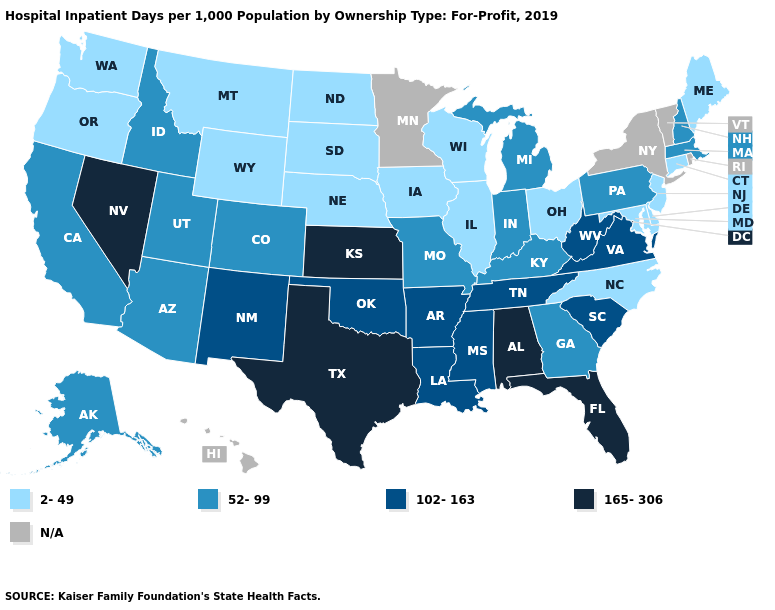Name the states that have a value in the range 102-163?
Answer briefly. Arkansas, Louisiana, Mississippi, New Mexico, Oklahoma, South Carolina, Tennessee, Virginia, West Virginia. What is the value of Iowa?
Quick response, please. 2-49. What is the highest value in the MidWest ?
Write a very short answer. 165-306. What is the highest value in the USA?
Short answer required. 165-306. What is the value of Kansas?
Short answer required. 165-306. Is the legend a continuous bar?
Keep it brief. No. What is the highest value in the West ?
Keep it brief. 165-306. What is the lowest value in the USA?
Short answer required. 2-49. How many symbols are there in the legend?
Short answer required. 5. Name the states that have a value in the range 102-163?
Keep it brief. Arkansas, Louisiana, Mississippi, New Mexico, Oklahoma, South Carolina, Tennessee, Virginia, West Virginia. What is the value of Wyoming?
Be succinct. 2-49. What is the lowest value in the USA?
Answer briefly. 2-49. Name the states that have a value in the range N/A?
Answer briefly. Hawaii, Minnesota, New York, Rhode Island, Vermont. What is the highest value in states that border South Carolina?
Concise answer only. 52-99. 